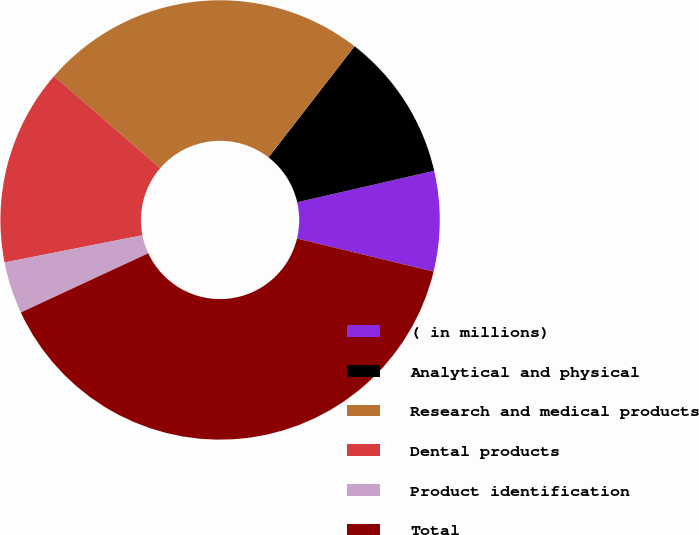<chart> <loc_0><loc_0><loc_500><loc_500><pie_chart><fcel>( in millions)<fcel>Analytical and physical<fcel>Research and medical products<fcel>Dental products<fcel>Product identification<fcel>Total<nl><fcel>7.37%<fcel>10.92%<fcel>24.13%<fcel>14.46%<fcel>3.82%<fcel>39.3%<nl></chart> 